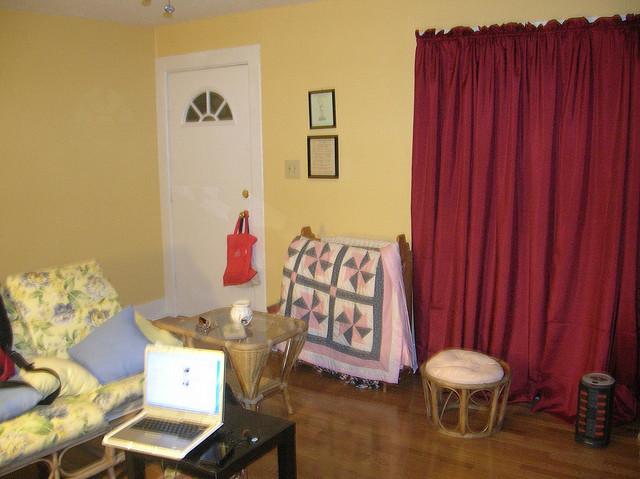What shape is the table in the foreground?
Write a very short answer. Square. This is what the inside of a typical persons home looks like?
Keep it brief. Yes. Is this a storage room?
Give a very brief answer. No. Is the room carpeted?
Quick response, please. No. Is there light coming through the windows?
Be succinct. No. What color are the blankets folded on the chair?
Answer briefly. Pink, gray and white. What holiday is the room decorated for?
Be succinct. None. What color is the pillow in the bottom left corner?
Be succinct. Blue. How are the curtains hung?
Answer briefly. Rods. What is below the table?
Keep it brief. Floor. Is this a dining table?
Concise answer only. No. What is hanging on the door?
Answer briefly. Bag. 